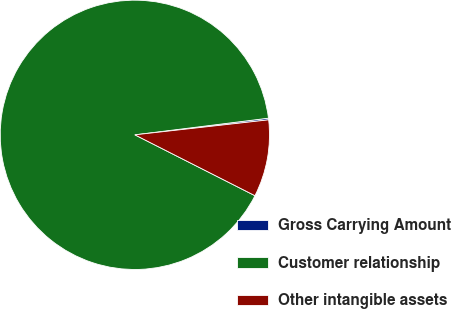<chart> <loc_0><loc_0><loc_500><loc_500><pie_chart><fcel>Gross Carrying Amount<fcel>Customer relationship<fcel>Other intangible assets<nl><fcel>0.2%<fcel>90.56%<fcel>9.24%<nl></chart> 